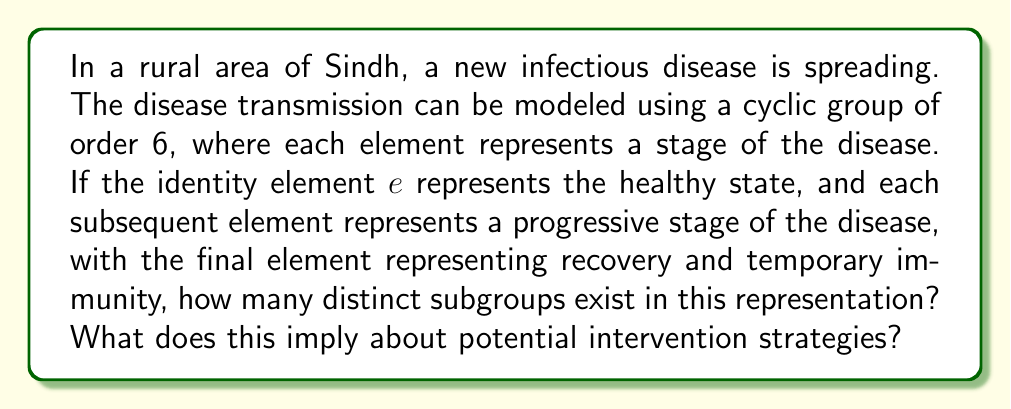Give your solution to this math problem. Let's approach this step-by-step:

1) The disease spread is modeled by the cyclic group $C_6 = \langle a \rangle = \{e, a, a^2, a^3, a^4, a^5\}$, where:
   $e$: healthy state
   $a$: initial infection
   $a^2, a^3, a^4$: progressive stages of the disease
   $a^5$: recovery and temporary immunity

2) To find the number of subgroups, we need to find the divisors of the group order:
   $|C_6| = 6$
   Divisors of 6 are: 1, 2, 3, 6

3) For each divisor $d$, there is exactly one subgroup of order $d$ in a cyclic group. Therefore, $C_6$ has 4 subgroups:
   - $\{e\}$ (order 1)
   - $\{e, a^3\}$ (order 2)
   - $\{e, a^2, a^4\}$ (order 3)
   - $C_6$ itself (order 6)

4) Interpretation for disease intervention:
   - The subgroup $\{e\}$ represents complete eradication (ideal but often unrealistic).
   - $\{e, a^3\}$ suggests a strategy that alternates between healthy and mid-stage disease states.
   - $\{e, a^2, a^4\}$ implies a three-stage cycle that could represent a recurring pattern of health, early infection, and late-stage disease.
   - The full group $C_6$ represents the natural progression of the disease without intervention.

5) These subgroups provide insights into potential cyclic patterns in the disease spread and suggest different levels of intervention, from complete eradication to managing recurring patterns.
Answer: 4 subgroups, implying 4 potential intervention strategies ranging from eradication to cyclic management. 